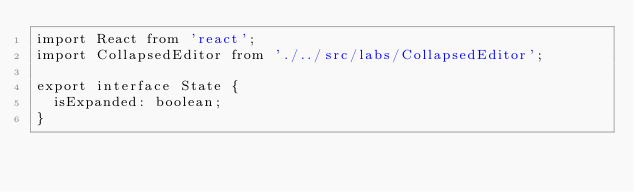Convert code to text. <code><loc_0><loc_0><loc_500><loc_500><_TypeScript_>import React from 'react';
import CollapsedEditor from './../src/labs/CollapsedEditor';

export interface State {
  isExpanded: boolean;
}</code> 